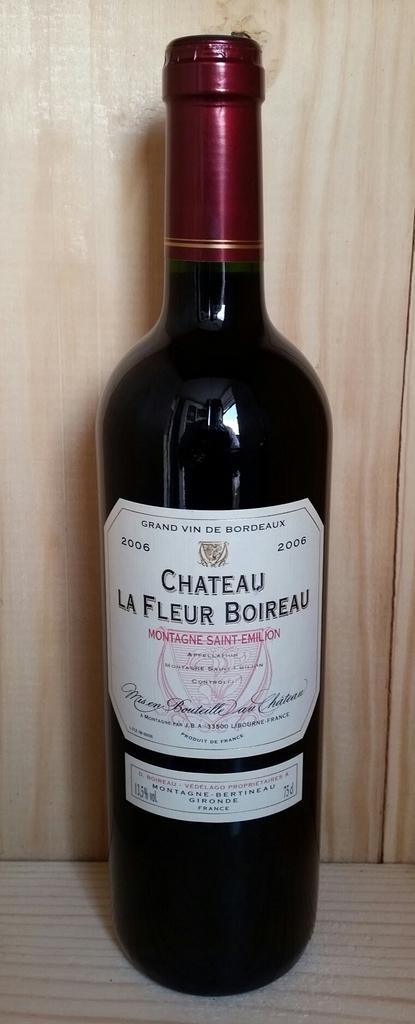What year is the wine?
Give a very brief answer. 2006. 